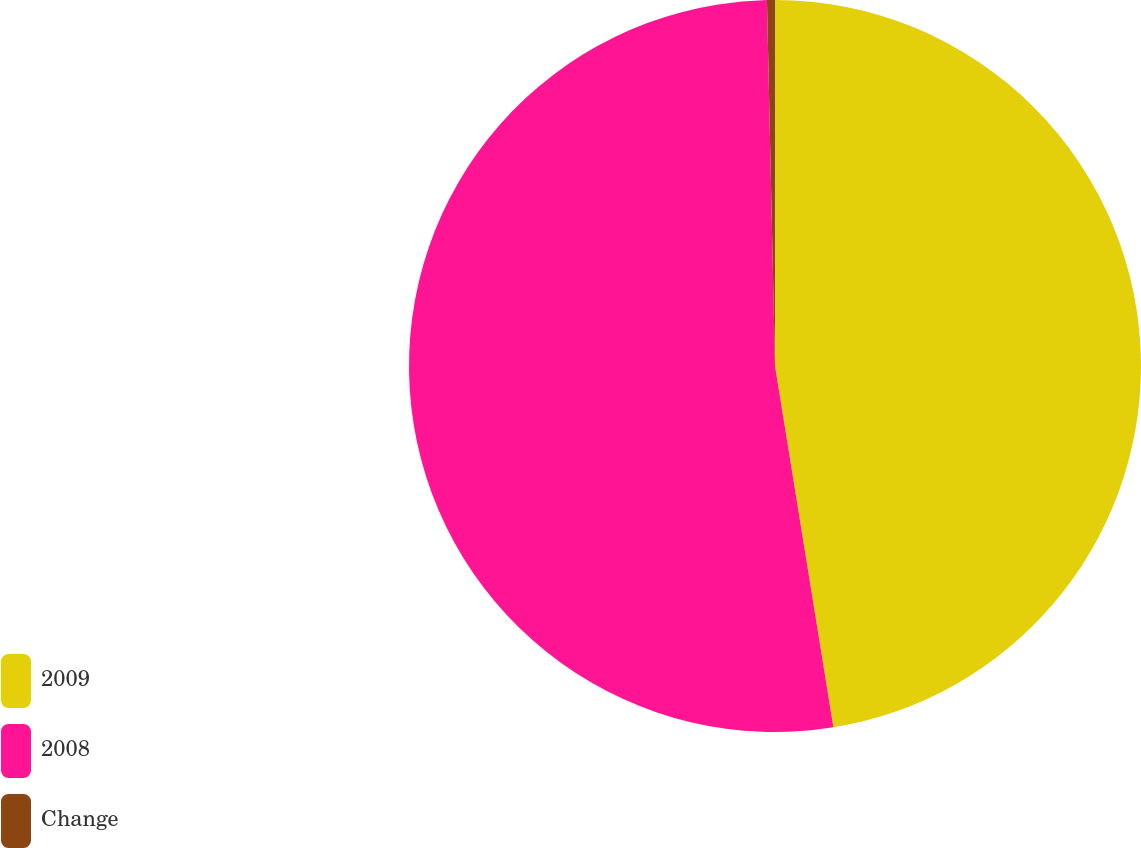<chart> <loc_0><loc_0><loc_500><loc_500><pie_chart><fcel>2009<fcel>2008<fcel>Change<nl><fcel>47.45%<fcel>52.2%<fcel>0.35%<nl></chart> 